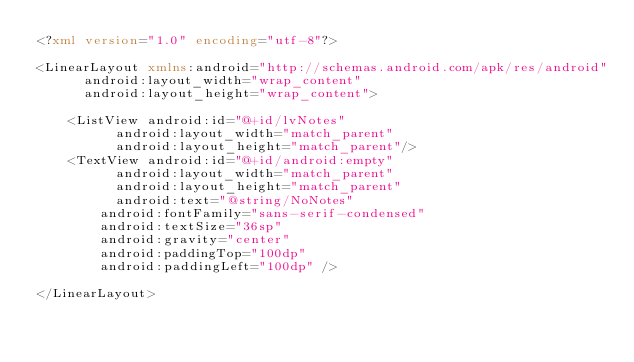<code> <loc_0><loc_0><loc_500><loc_500><_XML_><?xml version="1.0" encoding="utf-8"?>

<LinearLayout xmlns:android="http://schemas.android.com/apk/res/android"
      android:layout_width="wrap_content"
    	android:layout_height="wrap_content">

    <ListView android:id="@+id/lvNotes"
          android:layout_width="match_parent"
        	android:layout_height="match_parent"/>
  	<TextView android:id="@+id/android:empty"
          android:layout_width="match_parent"
        	android:layout_height="match_parent"
        	android:text="@string/NoNotes"
        android:fontFamily="sans-serif-condensed"
        android:textSize="36sp"
        android:gravity="center"
        android:paddingTop="100dp"
        android:paddingLeft="100dp" />

</LinearLayout>

</code> 